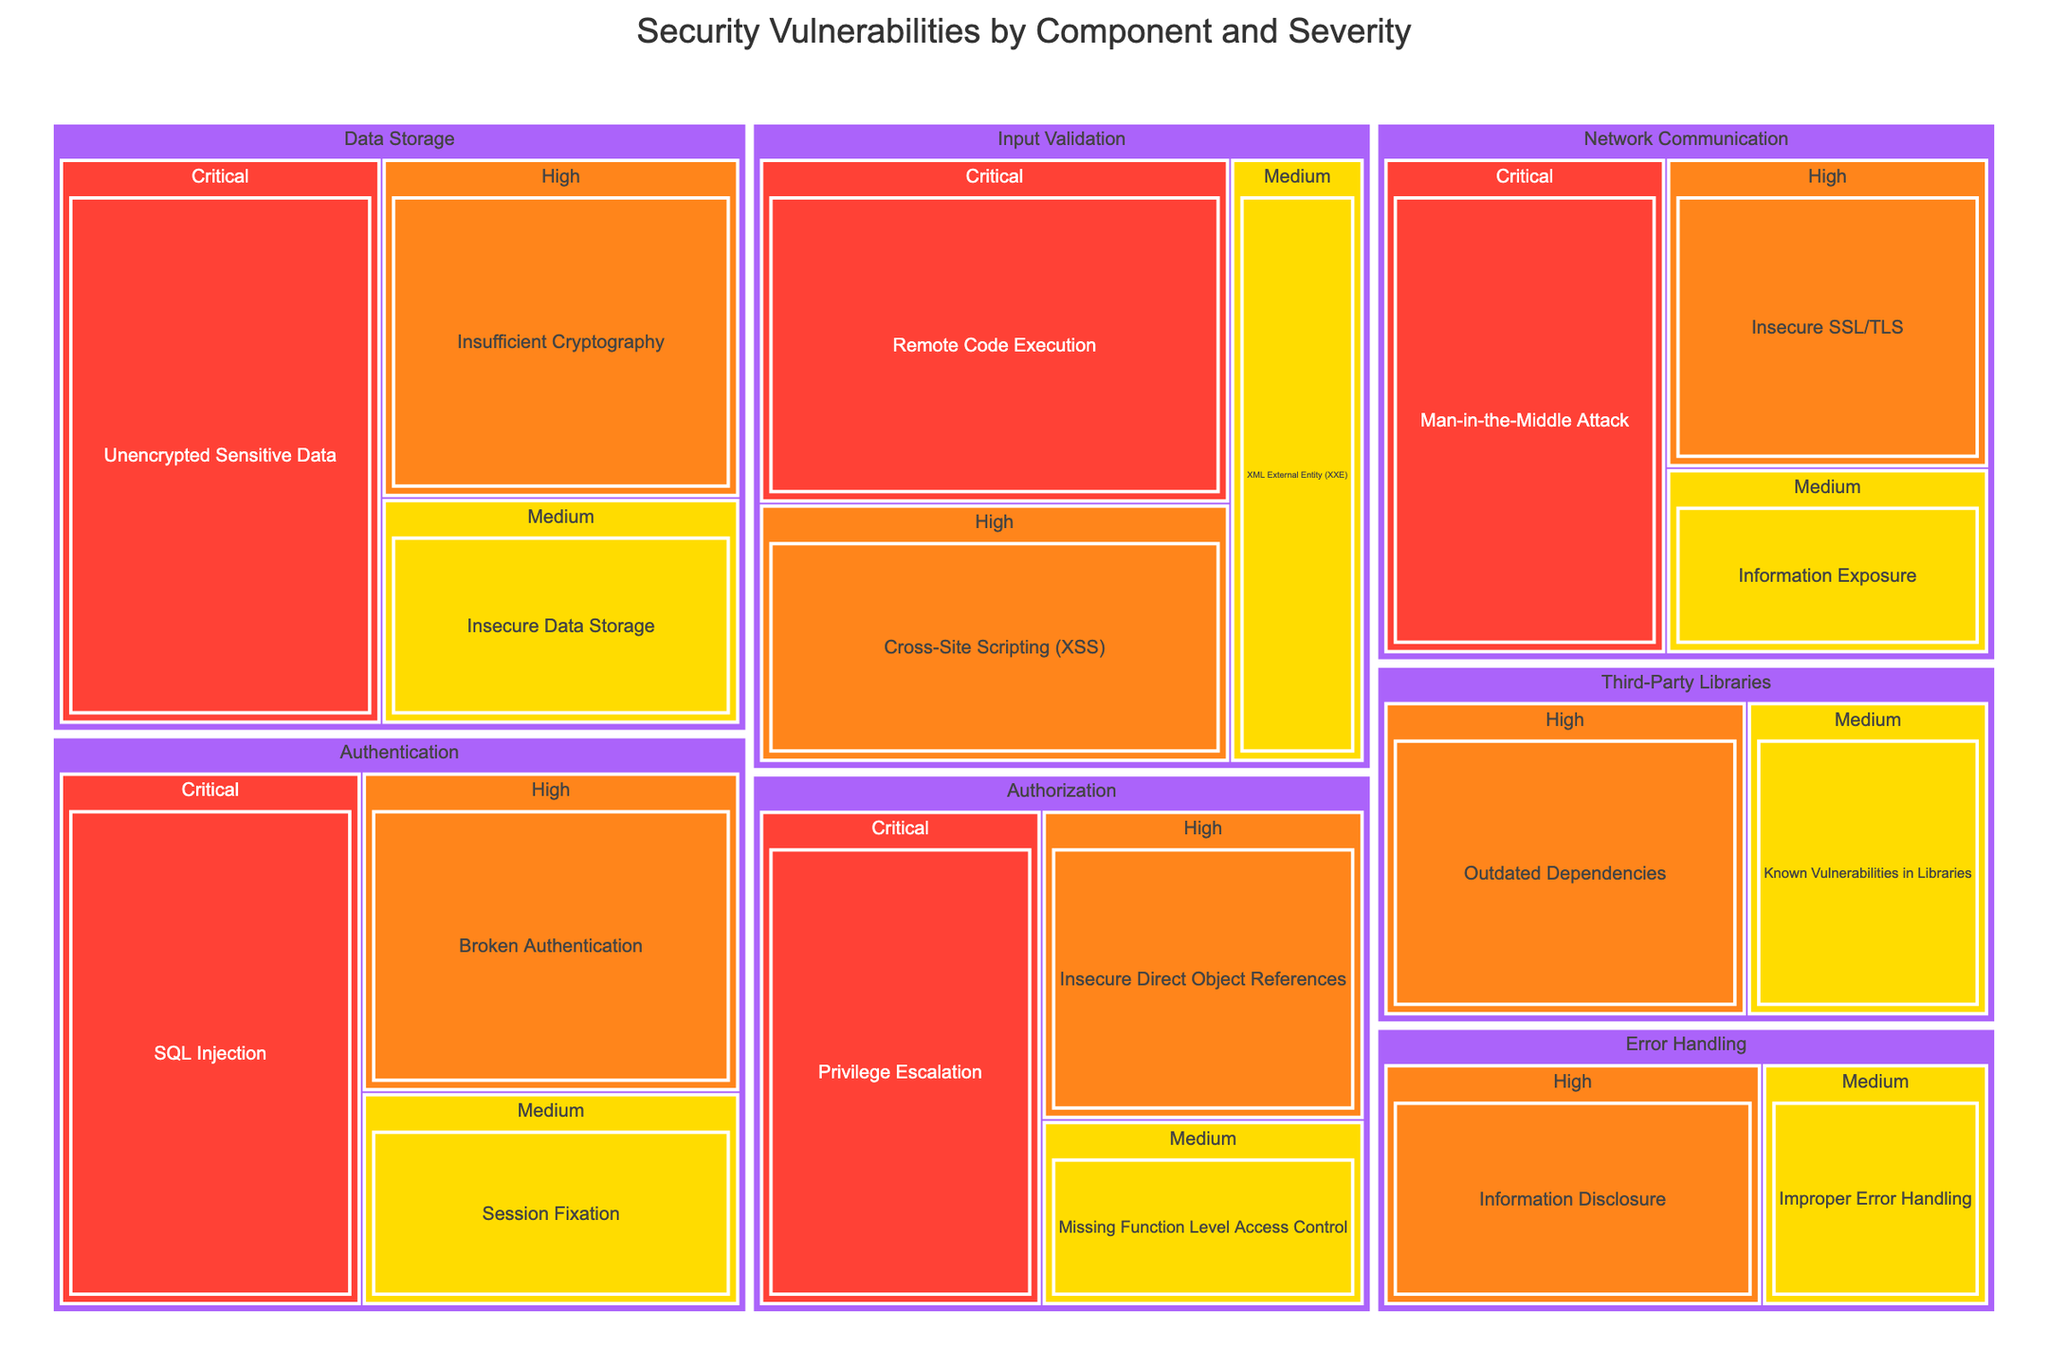What is the title of the treemap? The figure displays a title at the top center of the image which describes the overall subject of the treemap.
Answer: Security Vulnerabilities by Component and Severity Which component has the highest count of Critical vulnerabilities? To find the component with the highest count of Critical vulnerabilities, sum up the counts of all Critical vulnerabilities under each component and compare them.
Answer: Data Storage How many vulnerabilities are categorized as High severity for the Authentication component? Look for the Authentication component and then find the count of vulnerabilities under the High severity category.
Answer: 6 Which Critical vulnerability in Network Communication has the highest count? Within the Network Communication component, compare the counts of Critical vulnerabilities and identify the highest one.
Answer: Man-in-the-Middle Attack What is the total count of vulnerabilities in the Data Storage component? Sum up the counts of all vulnerabilities listed under the Data Storage component across all severities.
Answer: 19 How does the number of High severity vulnerabilities in Input Validation compare to those in Third-Party Libraries? Refer to the counts of High severity vulnerabilities for both Input Validation and Third-Party Libraries and compare the numbers.
Answer: 6 in Input Validation is equal to 6 in Third-Party Libraries Which component has the lowest count of Medium severity vulnerabilities? Compare the counts of Medium severity vulnerabilities across all components and identify the one with the lowest count.
Answer: Authorization What is the average count of vulnerabilities for the Medium severity category across all components? Add up the counts of Medium severity vulnerabilities across all components and divide by the number of components. (4 + 3 + 4 + 3 + 4 = 18, 18 / 5 = 3.6)
Answer: 3.6 Can you identify a component that has vulnerabilities across all severity categories (Critical, High, Medium)? Find a component where all three severity levels (Critical, High, Medium) are represented.
Answer: Authentication What is the most common severity level across all components? Sum the counts of vulnerabilities for each severity level (Critical, High, Medium) across all components and identify the most frequent one. (40 Critical, 39 High, 22 Medium)
Answer: Critical 